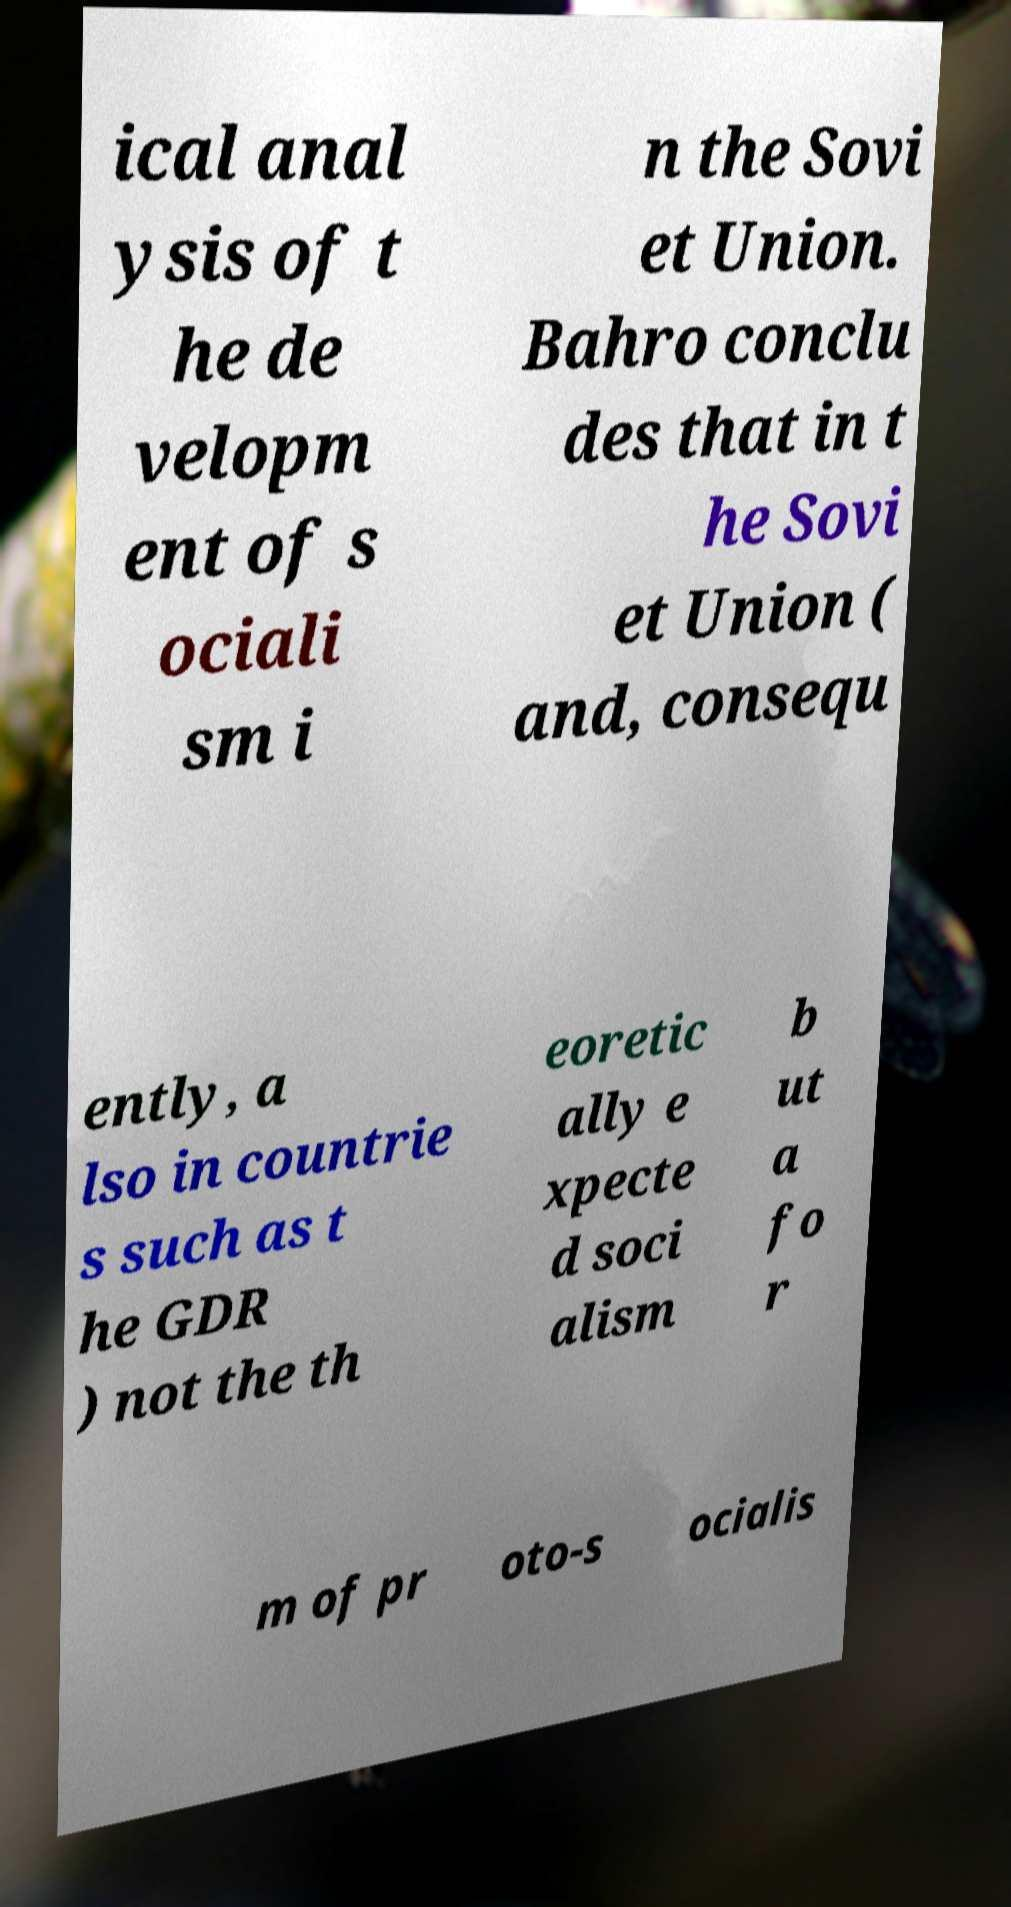Can you read and provide the text displayed in the image?This photo seems to have some interesting text. Can you extract and type it out for me? ical anal ysis of t he de velopm ent of s ociali sm i n the Sovi et Union. Bahro conclu des that in t he Sovi et Union ( and, consequ ently, a lso in countrie s such as t he GDR ) not the th eoretic ally e xpecte d soci alism b ut a fo r m of pr oto-s ocialis 